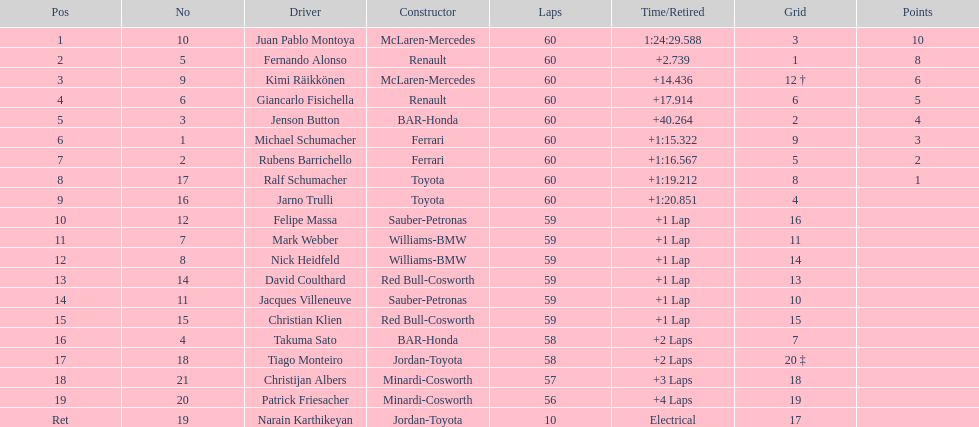How many drivers from germany? 3. 